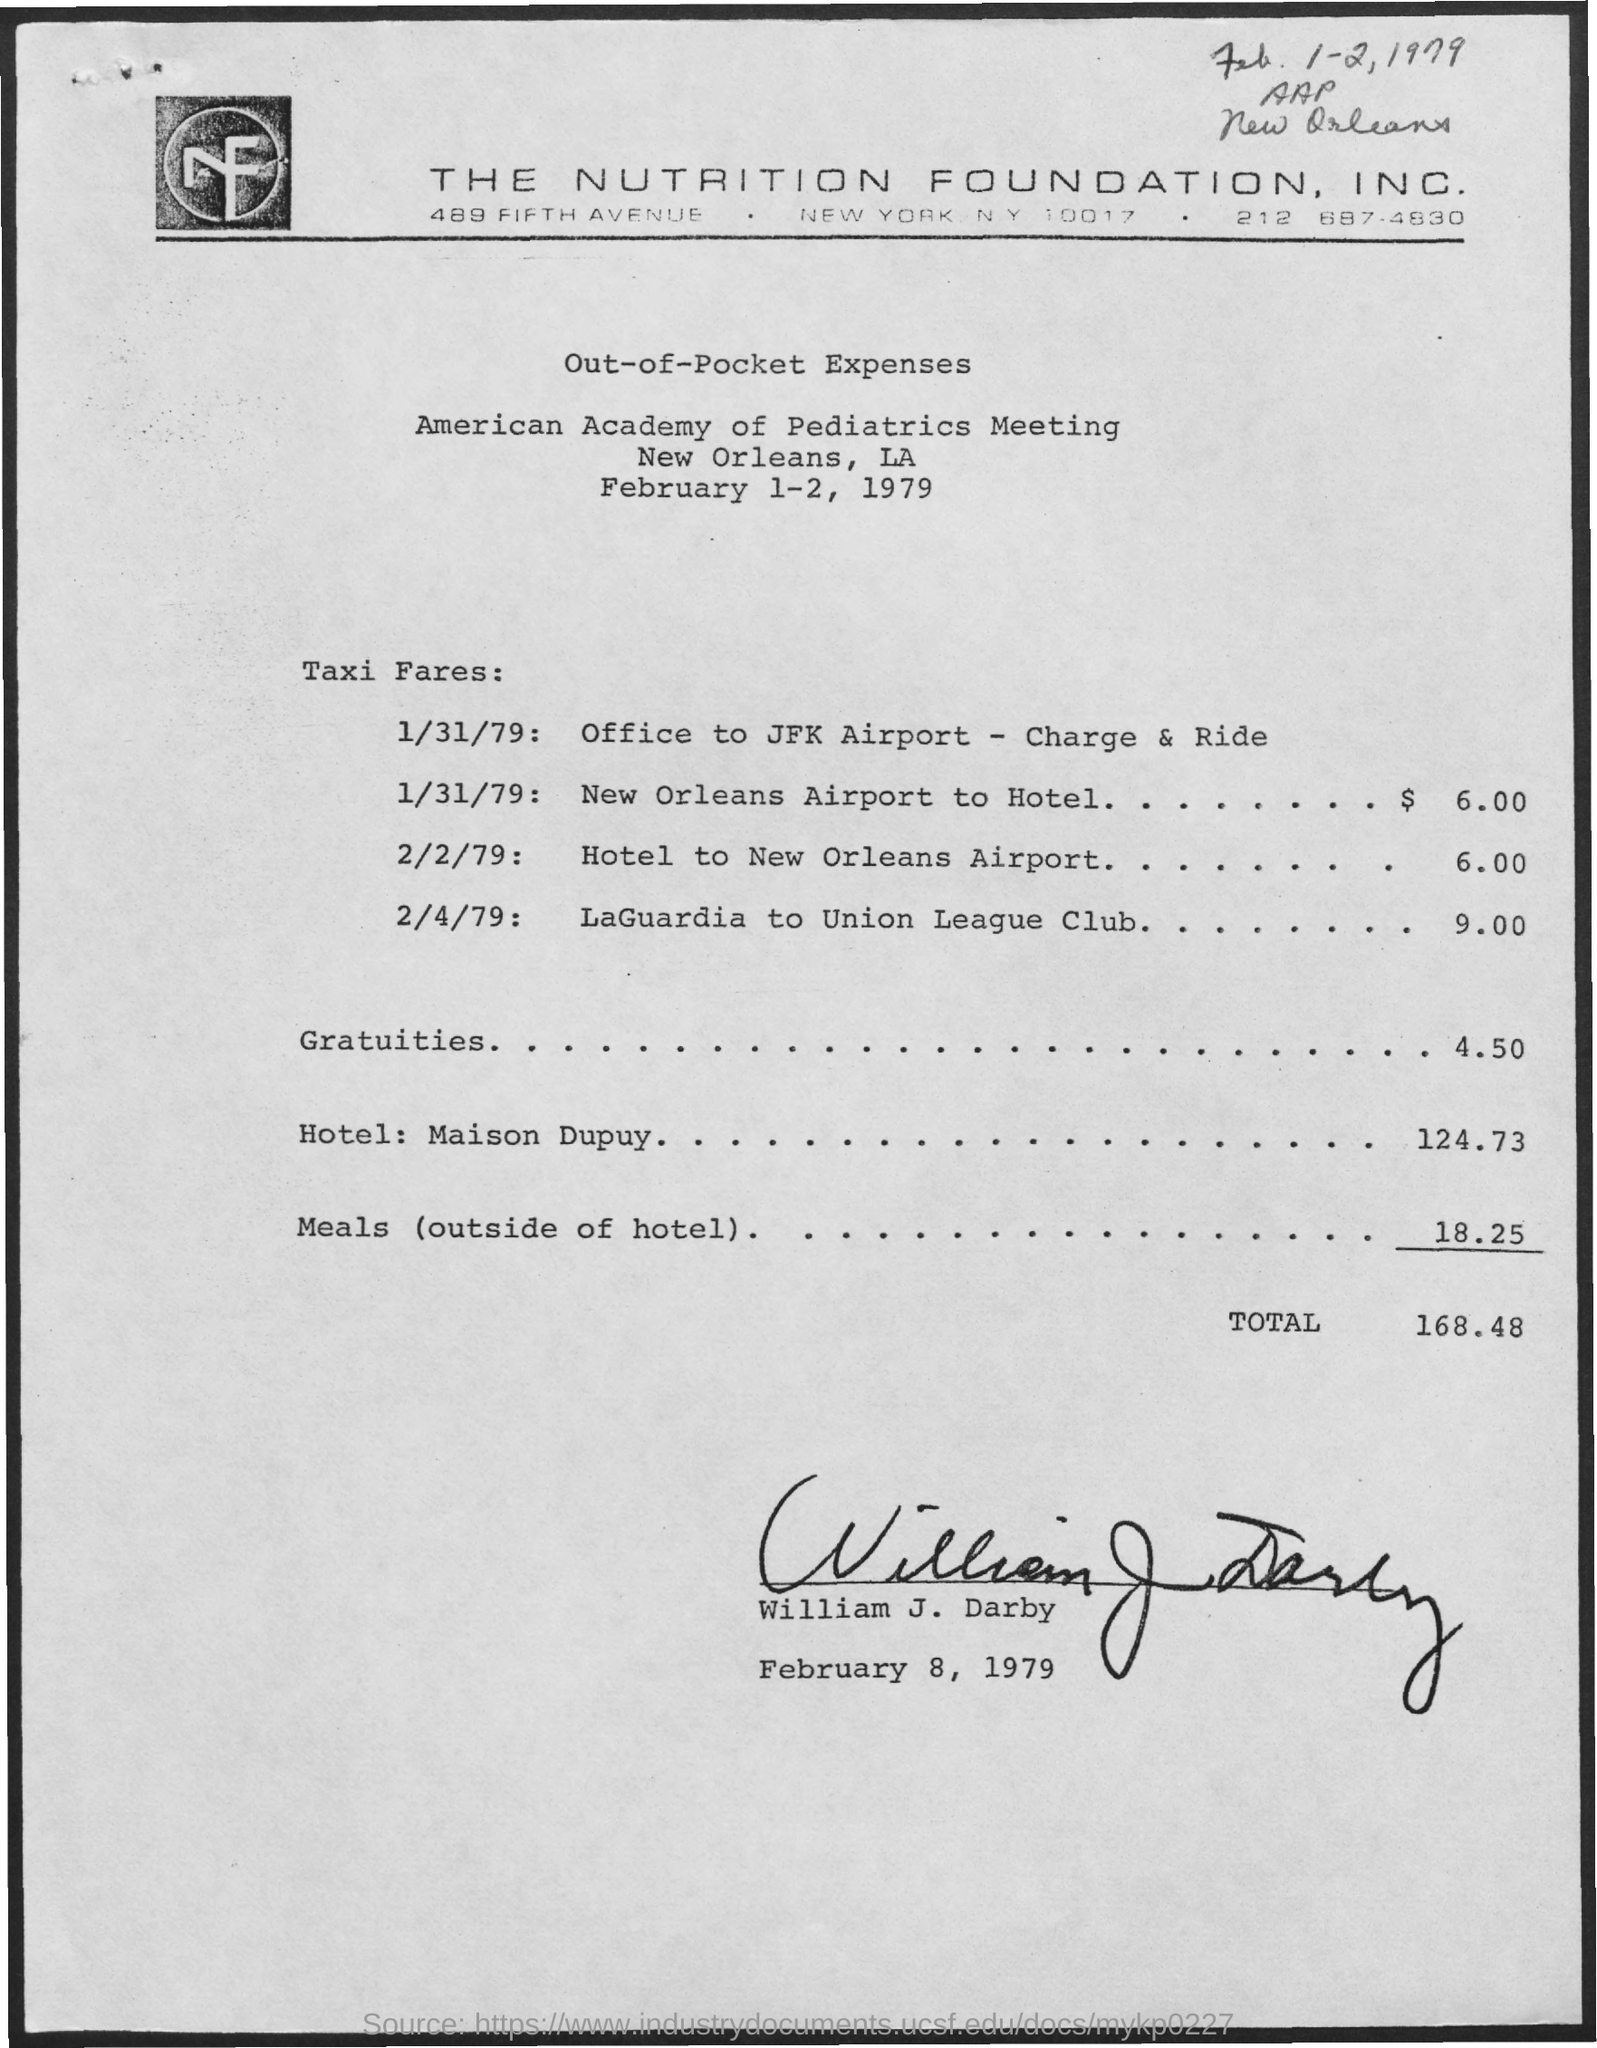Which meeting is this?
Your answer should be compact. American Academy of Pediatrics Meeting. What is the Total?
Make the answer very short. 168.48. What is the name of the person mentioned in the document?
Your answer should be very brief. William J. Darby. What is the amount of meals?
Offer a very short reply. 18.25. What is the taxi fare from the hotel to the New Orleans Airport on 2/2/79?
Your answer should be compact. 6.00. What is the taxi fare from the New Orleans Airport to the Hotel on 1/31/79?
Your answer should be very brief. $ 6.00. 